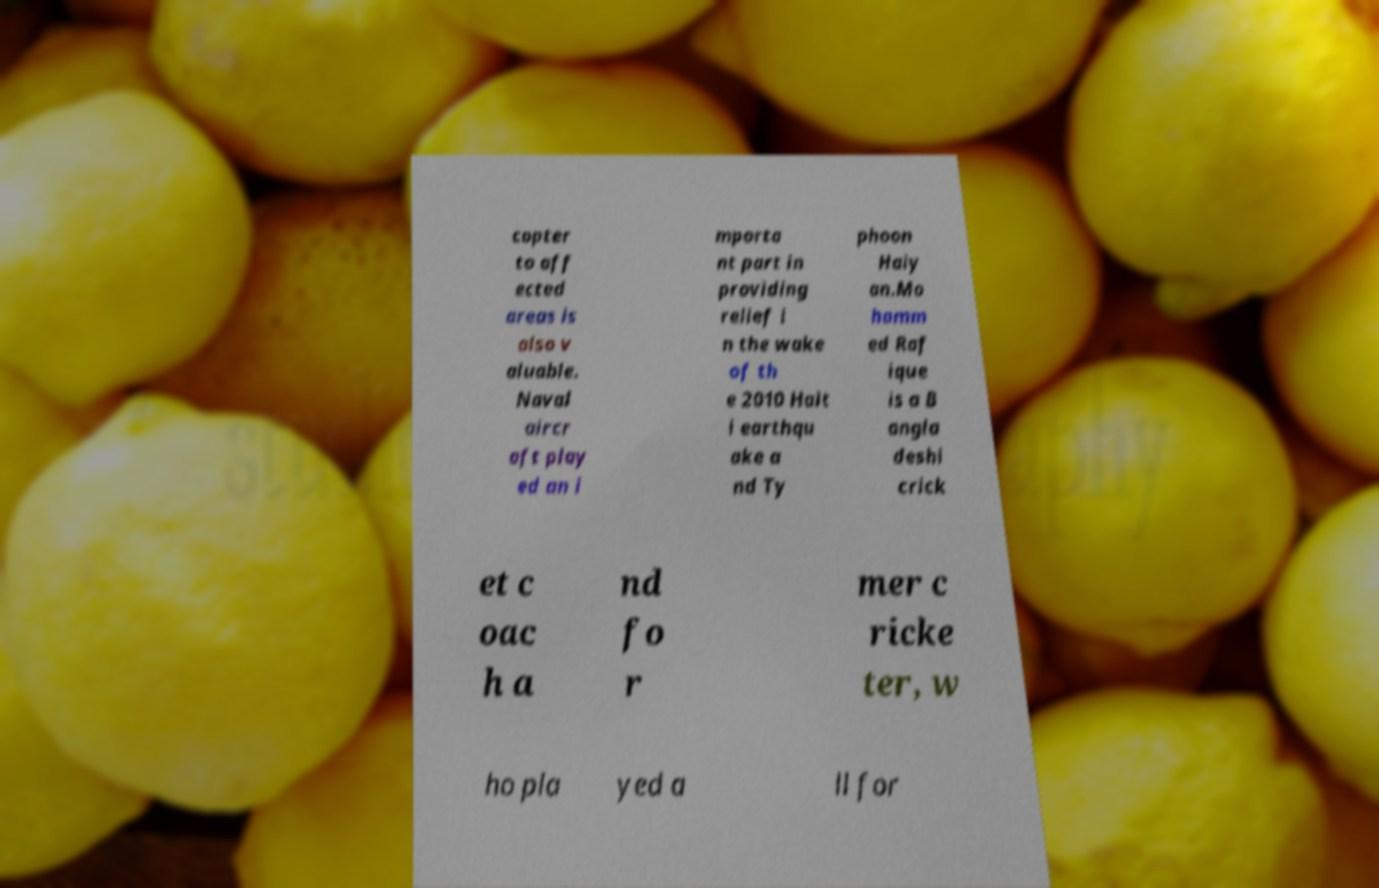Can you accurately transcribe the text from the provided image for me? copter to aff ected areas is also v aluable. Naval aircr aft play ed an i mporta nt part in providing relief i n the wake of th e 2010 Hait i earthqu ake a nd Ty phoon Haiy an.Mo hamm ed Raf ique is a B angla deshi crick et c oac h a nd fo r mer c ricke ter, w ho pla yed a ll for 